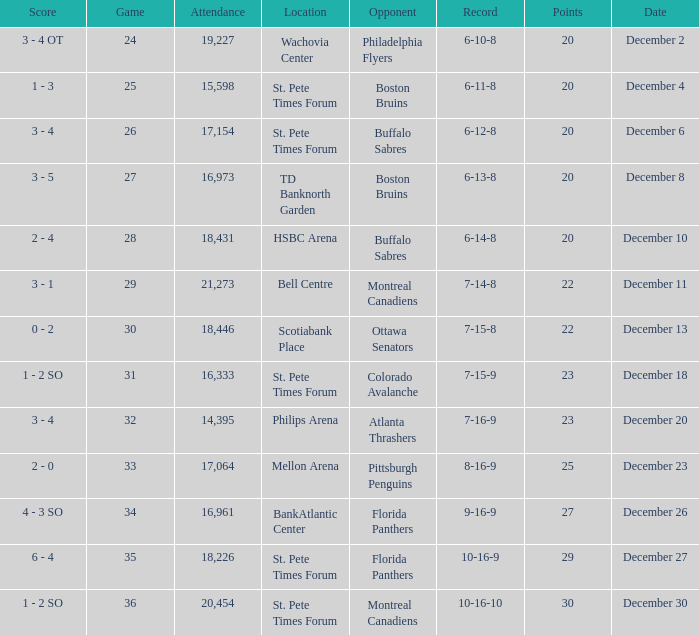What game has a 6-12-8 record? 26.0. 